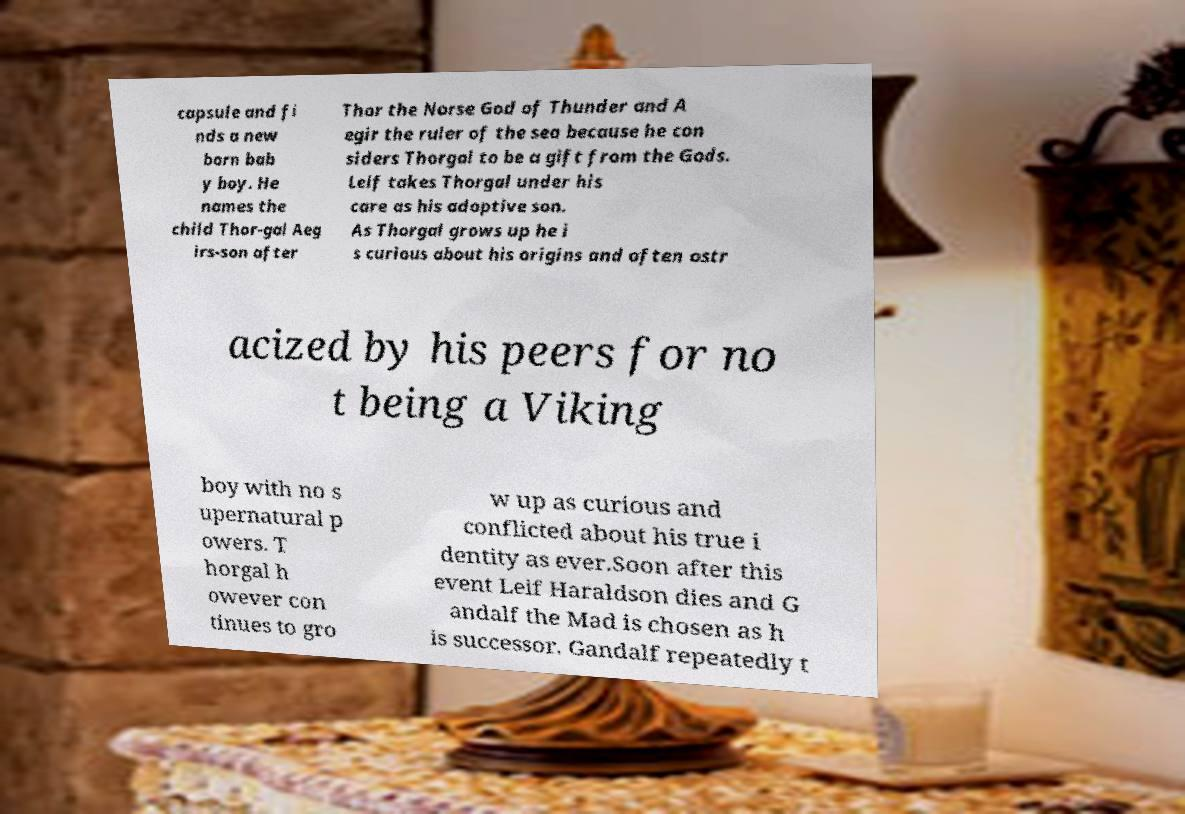What messages or text are displayed in this image? I need them in a readable, typed format. capsule and fi nds a new born bab y boy. He names the child Thor-gal Aeg irs-son after Thor the Norse God of Thunder and A egir the ruler of the sea because he con siders Thorgal to be a gift from the Gods. Leif takes Thorgal under his care as his adoptive son. As Thorgal grows up he i s curious about his origins and often ostr acized by his peers for no t being a Viking boy with no s upernatural p owers. T horgal h owever con tinues to gro w up as curious and conflicted about his true i dentity as ever.Soon after this event Leif Haraldson dies and G andalf the Mad is chosen as h is successor. Gandalf repeatedly t 